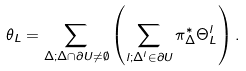Convert formula to latex. <formula><loc_0><loc_0><loc_500><loc_500>\theta _ { L } = \sum _ { \Delta ; \Delta \cap \partial U \not = \emptyset } \left ( \sum _ { l ; \Delta ^ { l } \in \partial U } \pi _ { \Delta } ^ { * } \Theta ^ { l } _ { L } \right ) .</formula> 